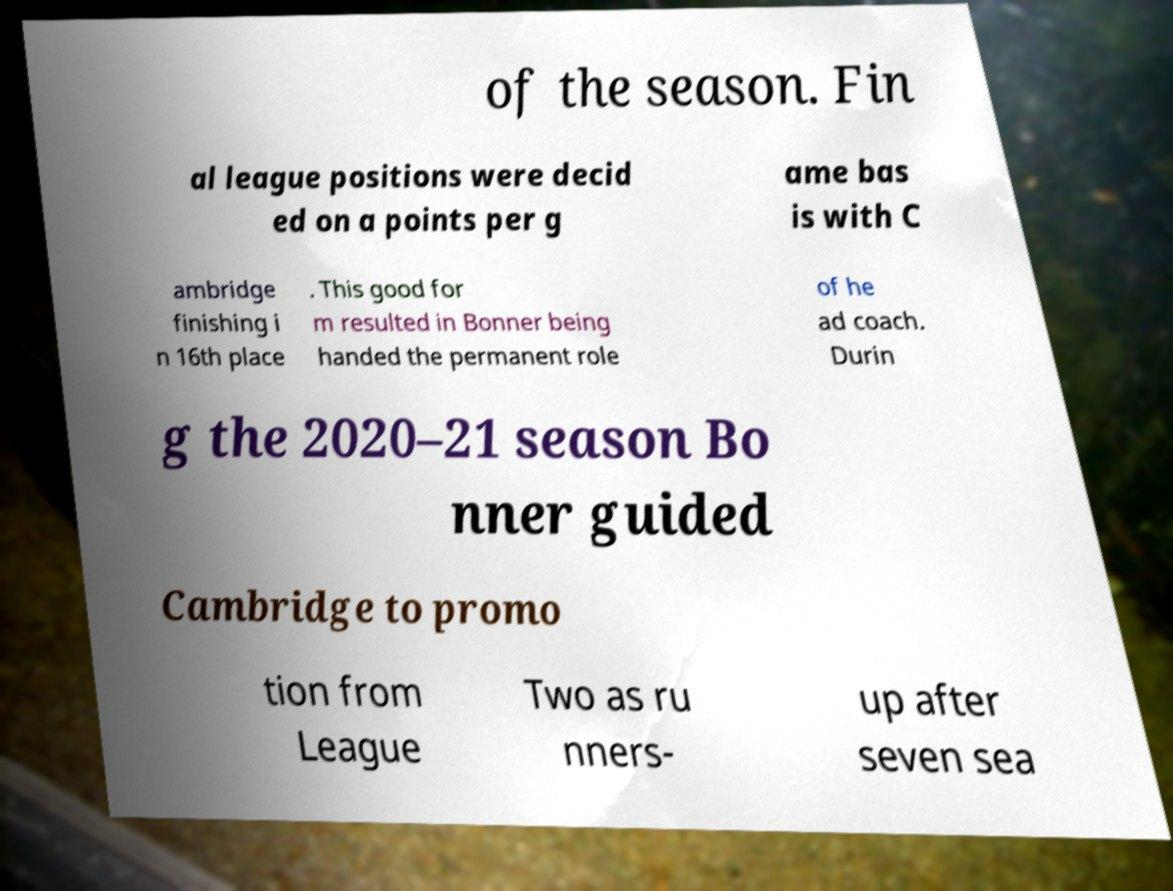For documentation purposes, I need the text within this image transcribed. Could you provide that? of the season. Fin al league positions were decid ed on a points per g ame bas is with C ambridge finishing i n 16th place . This good for m resulted in Bonner being handed the permanent role of he ad coach. Durin g the 2020–21 season Bo nner guided Cambridge to promo tion from League Two as ru nners- up after seven sea 